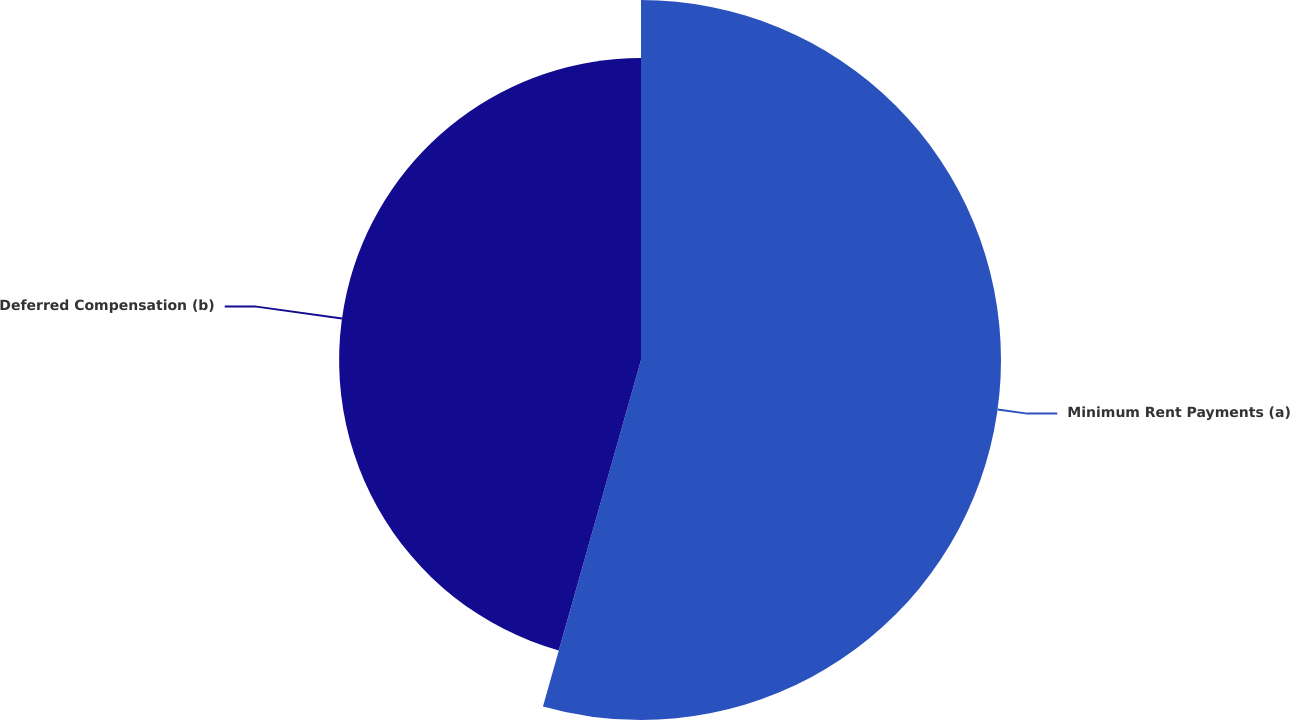Convert chart to OTSL. <chart><loc_0><loc_0><loc_500><loc_500><pie_chart><fcel>Minimum Rent Payments (a)<fcel>Deferred Compensation (b)<nl><fcel>54.39%<fcel>45.61%<nl></chart> 